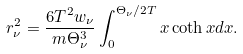Convert formula to latex. <formula><loc_0><loc_0><loc_500><loc_500>r _ { \nu } ^ { 2 } = \frac { 6 T ^ { 2 } w _ { \nu } } { m \Theta _ { \nu } ^ { 3 } } \int _ { 0 } ^ { \Theta _ { \nu } / 2 T } x \coth x d x .</formula> 